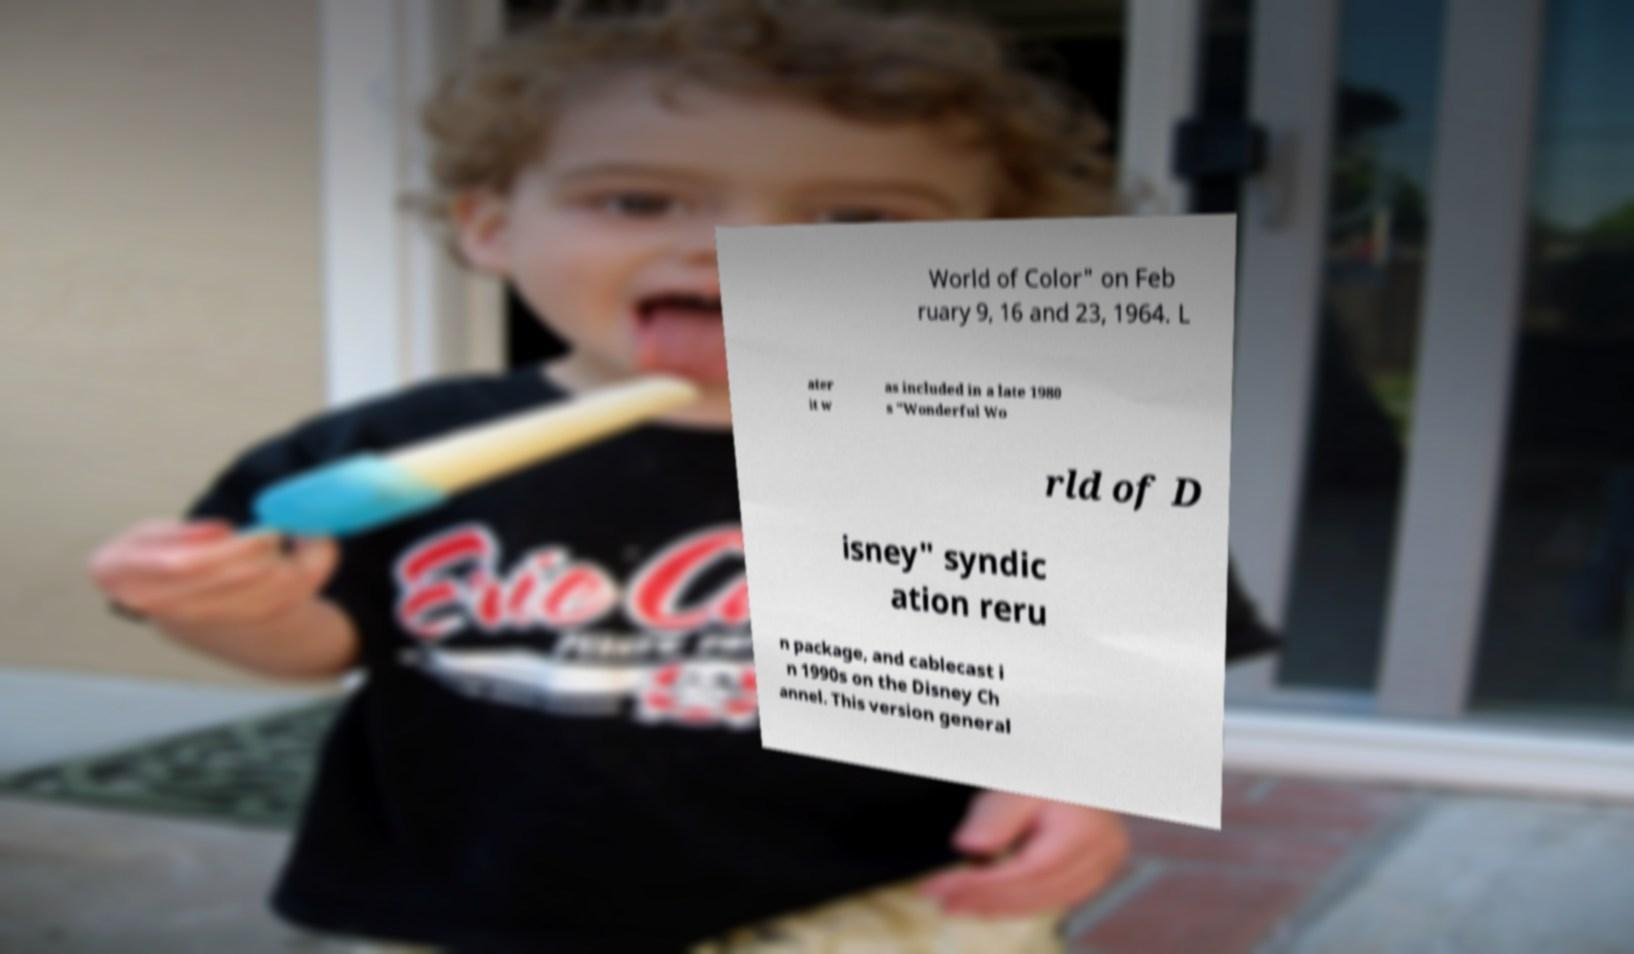For documentation purposes, I need the text within this image transcribed. Could you provide that? World of Color" on Feb ruary 9, 16 and 23, 1964. L ater it w as included in a late 1980 s "Wonderful Wo rld of D isney" syndic ation reru n package, and cablecast i n 1990s on the Disney Ch annel. This version general 